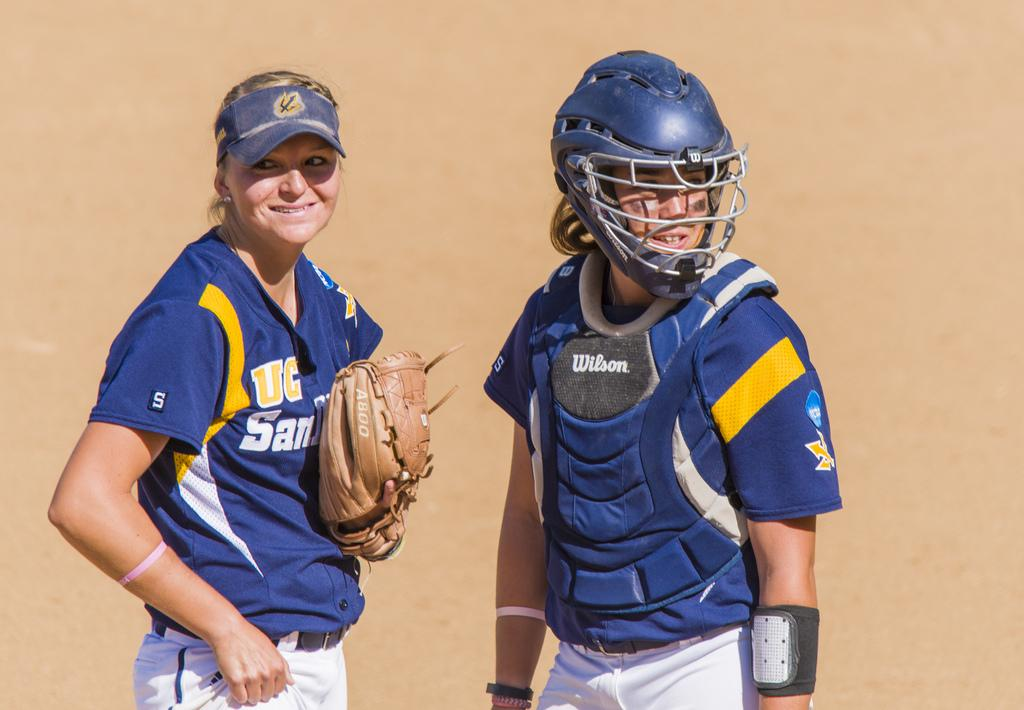<image>
Describe the image concisely. Two sports women, the left of whom has UC visible on their chest. 